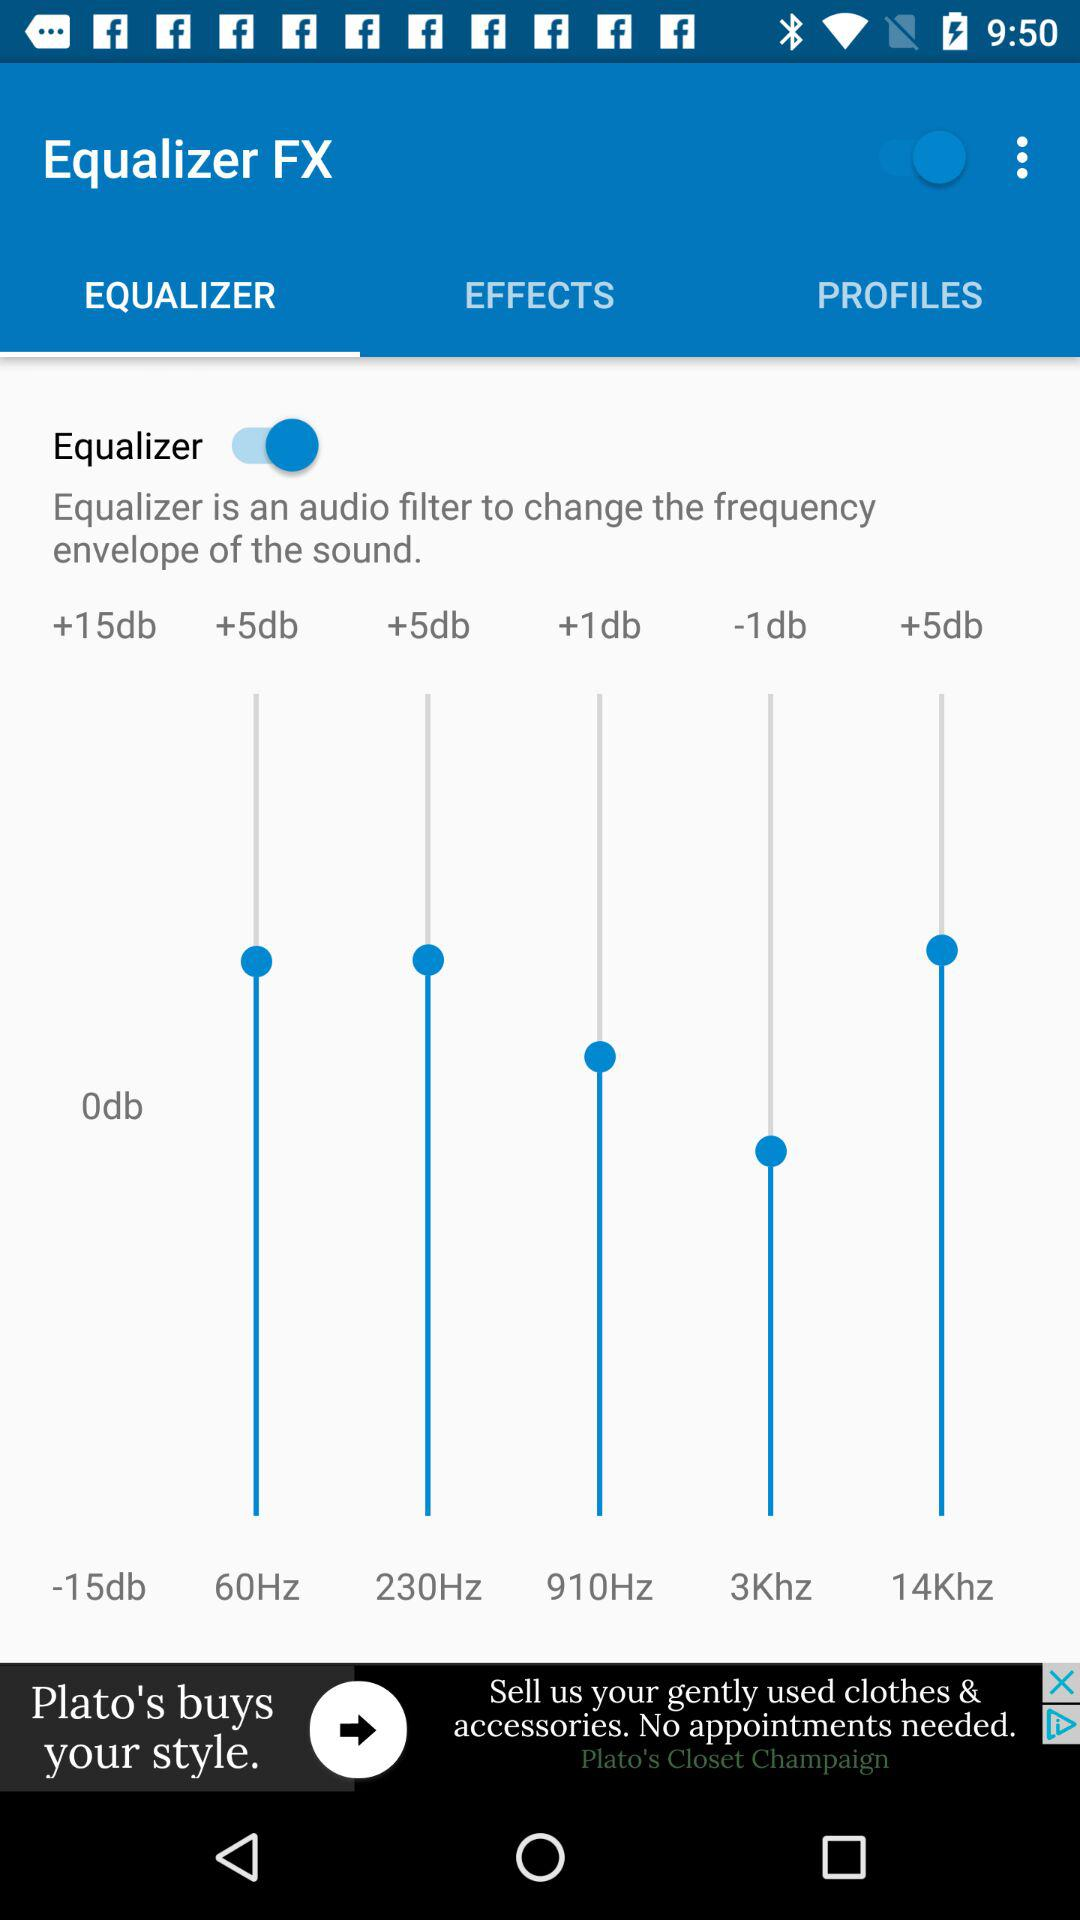What is the status of "Equalizer"? The status of "Equalizer" is "on". 